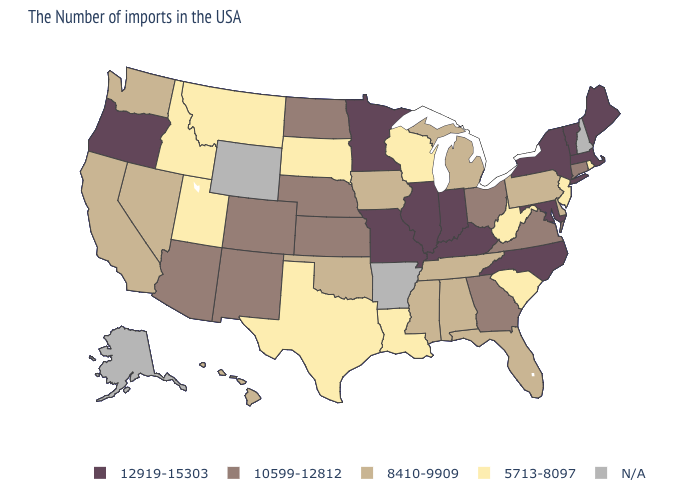What is the highest value in states that border Mississippi?
Be succinct. 8410-9909. What is the value of Maine?
Quick response, please. 12919-15303. What is the value of Montana?
Quick response, please. 5713-8097. Which states have the highest value in the USA?
Concise answer only. Maine, Massachusetts, Vermont, New York, Maryland, North Carolina, Kentucky, Indiana, Illinois, Missouri, Minnesota, Oregon. Does Missouri have the highest value in the USA?
Be succinct. Yes. What is the lowest value in states that border California?
Concise answer only. 8410-9909. Which states have the lowest value in the West?
Be succinct. Utah, Montana, Idaho. What is the value of Florida?
Write a very short answer. 8410-9909. What is the highest value in states that border Montana?
Quick response, please. 10599-12812. What is the highest value in states that border South Carolina?
Keep it brief. 12919-15303. What is the value of Iowa?
Be succinct. 8410-9909. What is the value of Georgia?
Concise answer only. 10599-12812. What is the lowest value in states that border Louisiana?
Keep it brief. 5713-8097. 